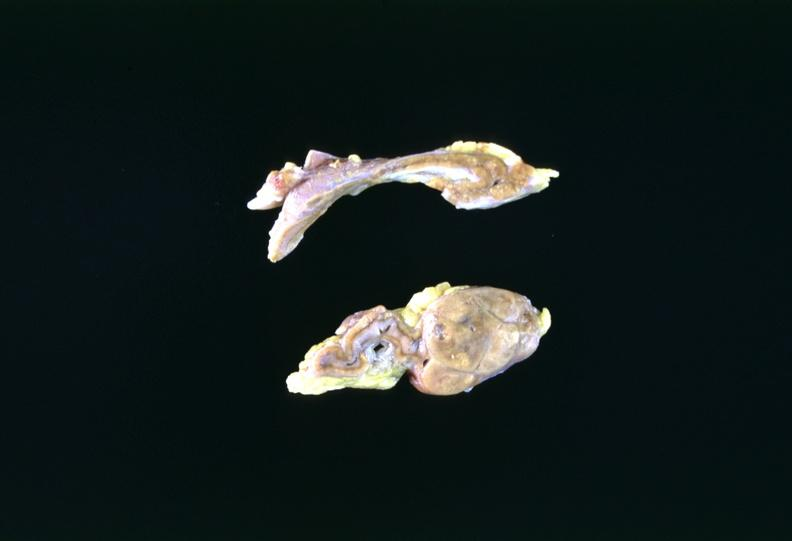does infant body show adrenal tumor?
Answer the question using a single word or phrase. No 